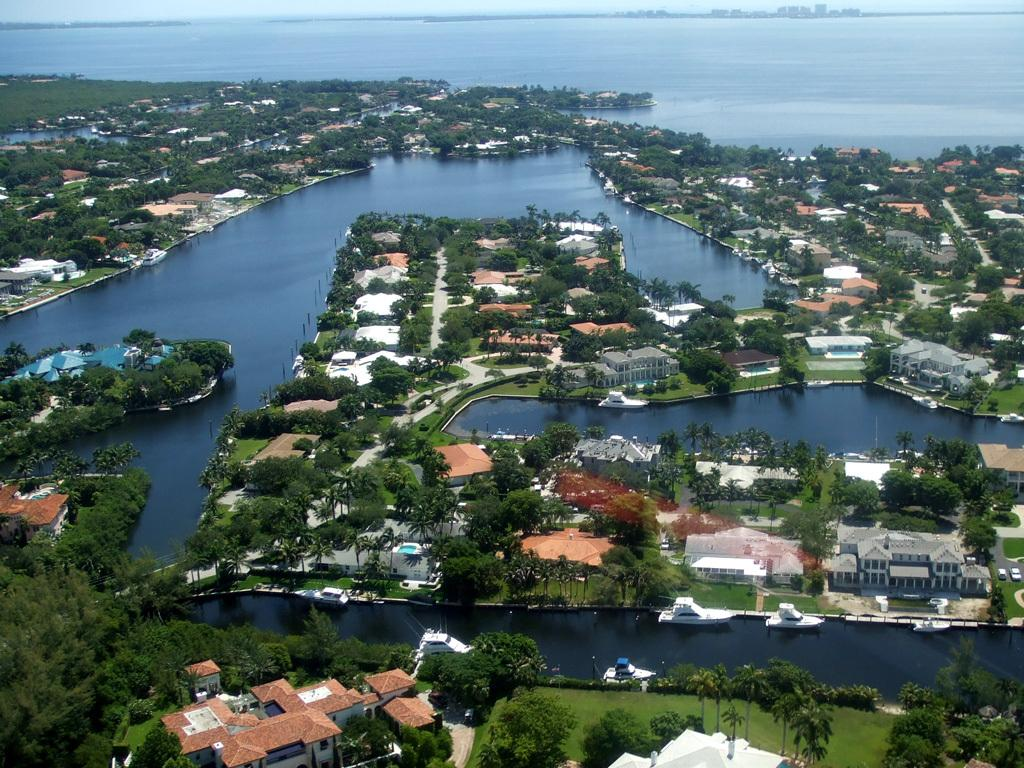What type of natural feature is present in the image? There is an ocean in the image. What type of man-made structures can be seen in the image? There are buildings in the image. What type of vegetation is present in the image? There are trees in the image. What type of street furniture is present in the image? There are street poles in the image. What type of surface is visible in the image? The ground is visible in the image. What type of glue is being used to hold the buildings together in the image? There is no indication of glue being used to hold the buildings together in the image. What type of fiction is being read by the trees in the image? There are no people or animals present in the image, let alone anyone reading fiction. 